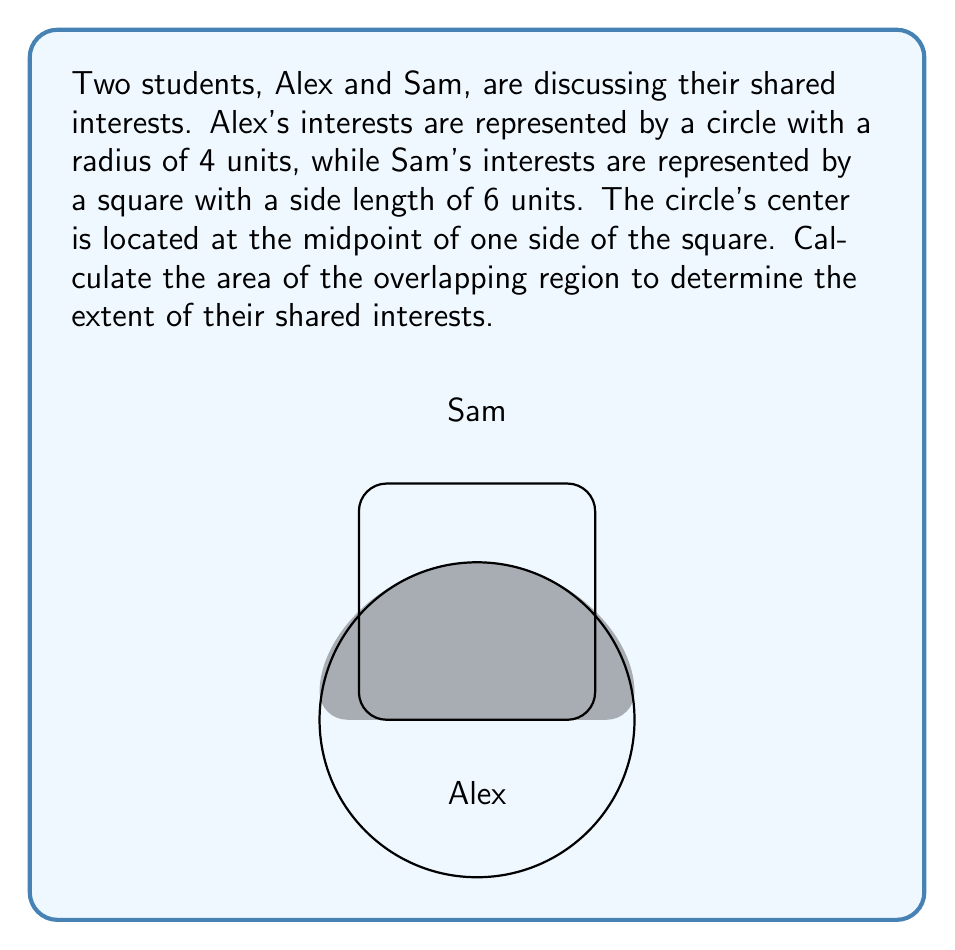Help me with this question. To solve this problem, we need to follow these steps:

1) First, we need to find the area of the semicircle that overlaps with the square.
   The area of a semicircle is given by the formula: $A = \frac{1}{2} \pi r^2$
   
   $A_{semicircle} = \frac{1}{2} \pi (4)^2 = 8\pi$ square units

2) Next, we need to find the area of the triangle formed by the circle's center and the points where the circle intersects the square.
   The base of this triangle is the side of the square (6 units), and the height is the radius (4 units).
   
   $A_{triangle} = \frac{1}{2} \times base \times height = \frac{1}{2} \times 6 \times 4 = 12$ square units

3) The overlapping area is the difference between the semicircle area and the triangle area:

   $A_{overlap} = A_{semicircle} - A_{triangle} = 8\pi - 12$ square units

4) To simplify:
   $8\pi - 12 \approx 25.13 - 12 = 13.13$ square units

Therefore, the area of shared interests is approximately 13.13 square units.
Answer: $8\pi - 12$ square units 